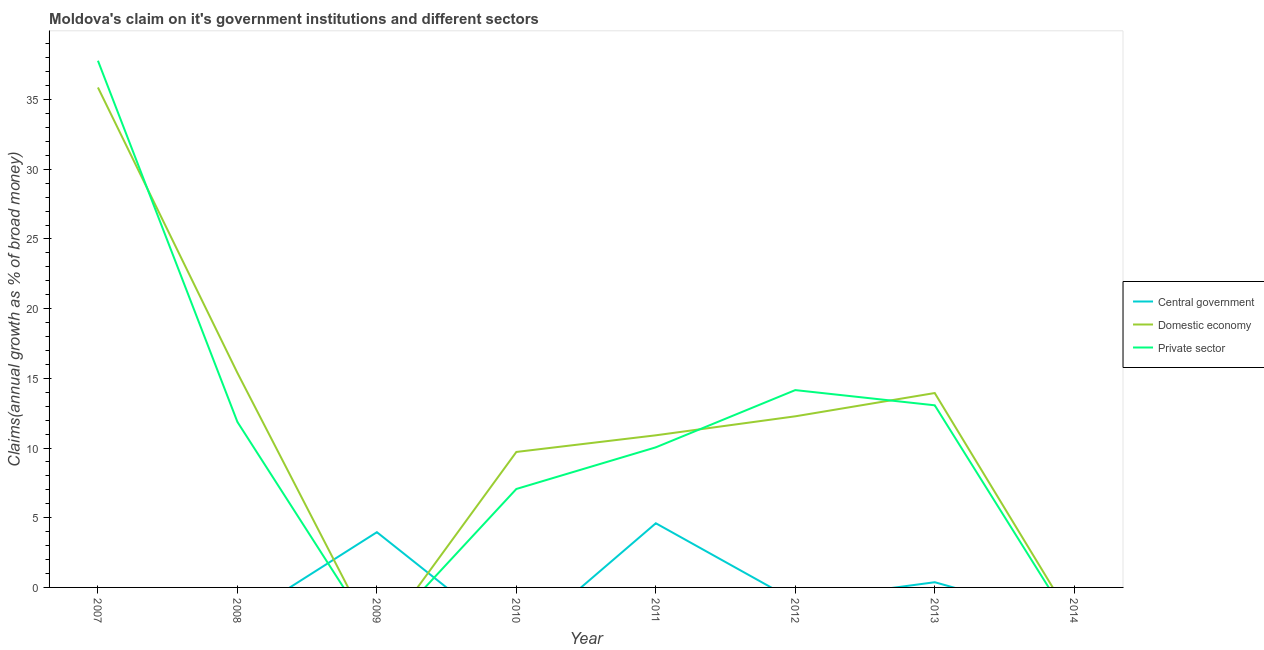What is the percentage of claim on the private sector in 2010?
Ensure brevity in your answer.  7.06. Across all years, what is the maximum percentage of claim on the domestic economy?
Offer a very short reply. 35.87. Across all years, what is the minimum percentage of claim on the central government?
Make the answer very short. 0. What is the total percentage of claim on the private sector in the graph?
Ensure brevity in your answer.  94. What is the difference between the percentage of claim on the central government in 2009 and that in 2011?
Your answer should be compact. -0.64. What is the average percentage of claim on the central government per year?
Your response must be concise. 1.12. In the year 2013, what is the difference between the percentage of claim on the private sector and percentage of claim on the domestic economy?
Give a very brief answer. -0.88. In how many years, is the percentage of claim on the central government greater than 22 %?
Offer a very short reply. 0. What is the ratio of the percentage of claim on the private sector in 2008 to that in 2013?
Your answer should be very brief. 0.91. What is the difference between the highest and the second highest percentage of claim on the private sector?
Provide a short and direct response. 23.63. What is the difference between the highest and the lowest percentage of claim on the domestic economy?
Keep it short and to the point. 35.87. Is the sum of the percentage of claim on the central government in 2009 and 2011 greater than the maximum percentage of claim on the private sector across all years?
Your answer should be very brief. No. Is it the case that in every year, the sum of the percentage of claim on the central government and percentage of claim on the domestic economy is greater than the percentage of claim on the private sector?
Make the answer very short. No. Does the percentage of claim on the private sector monotonically increase over the years?
Your answer should be compact. No. Is the percentage of claim on the central government strictly greater than the percentage of claim on the domestic economy over the years?
Your answer should be compact. No. How many years are there in the graph?
Provide a short and direct response. 8. Are the values on the major ticks of Y-axis written in scientific E-notation?
Offer a terse response. No. Does the graph contain grids?
Your answer should be compact. No. What is the title of the graph?
Provide a succinct answer. Moldova's claim on it's government institutions and different sectors. What is the label or title of the Y-axis?
Keep it short and to the point. Claims(annual growth as % of broad money). What is the Claims(annual growth as % of broad money) in Domestic economy in 2007?
Make the answer very short. 35.87. What is the Claims(annual growth as % of broad money) in Private sector in 2007?
Give a very brief answer. 37.79. What is the Claims(annual growth as % of broad money) in Central government in 2008?
Provide a succinct answer. 0. What is the Claims(annual growth as % of broad money) in Domestic economy in 2008?
Provide a short and direct response. 15.39. What is the Claims(annual growth as % of broad money) in Private sector in 2008?
Ensure brevity in your answer.  11.87. What is the Claims(annual growth as % of broad money) in Central government in 2009?
Make the answer very short. 3.96. What is the Claims(annual growth as % of broad money) in Private sector in 2009?
Offer a very short reply. 0. What is the Claims(annual growth as % of broad money) of Domestic economy in 2010?
Ensure brevity in your answer.  9.72. What is the Claims(annual growth as % of broad money) in Private sector in 2010?
Offer a very short reply. 7.06. What is the Claims(annual growth as % of broad money) of Central government in 2011?
Offer a very short reply. 4.6. What is the Claims(annual growth as % of broad money) in Domestic economy in 2011?
Your response must be concise. 10.91. What is the Claims(annual growth as % of broad money) of Private sector in 2011?
Make the answer very short. 10.05. What is the Claims(annual growth as % of broad money) of Central government in 2012?
Offer a very short reply. 0. What is the Claims(annual growth as % of broad money) in Domestic economy in 2012?
Ensure brevity in your answer.  12.28. What is the Claims(annual growth as % of broad money) of Private sector in 2012?
Keep it short and to the point. 14.16. What is the Claims(annual growth as % of broad money) in Central government in 2013?
Your answer should be compact. 0.37. What is the Claims(annual growth as % of broad money) of Domestic economy in 2013?
Give a very brief answer. 13.95. What is the Claims(annual growth as % of broad money) of Private sector in 2013?
Provide a short and direct response. 13.07. Across all years, what is the maximum Claims(annual growth as % of broad money) in Central government?
Provide a short and direct response. 4.6. Across all years, what is the maximum Claims(annual growth as % of broad money) in Domestic economy?
Your answer should be compact. 35.87. Across all years, what is the maximum Claims(annual growth as % of broad money) of Private sector?
Offer a terse response. 37.79. Across all years, what is the minimum Claims(annual growth as % of broad money) in Private sector?
Offer a terse response. 0. What is the total Claims(annual growth as % of broad money) in Central government in the graph?
Ensure brevity in your answer.  8.94. What is the total Claims(annual growth as % of broad money) in Domestic economy in the graph?
Provide a short and direct response. 98.12. What is the total Claims(annual growth as % of broad money) in Private sector in the graph?
Provide a succinct answer. 94. What is the difference between the Claims(annual growth as % of broad money) in Domestic economy in 2007 and that in 2008?
Keep it short and to the point. 20.48. What is the difference between the Claims(annual growth as % of broad money) of Private sector in 2007 and that in 2008?
Offer a very short reply. 25.92. What is the difference between the Claims(annual growth as % of broad money) of Domestic economy in 2007 and that in 2010?
Provide a short and direct response. 26.15. What is the difference between the Claims(annual growth as % of broad money) in Private sector in 2007 and that in 2010?
Offer a very short reply. 30.73. What is the difference between the Claims(annual growth as % of broad money) of Domestic economy in 2007 and that in 2011?
Your response must be concise. 24.96. What is the difference between the Claims(annual growth as % of broad money) of Private sector in 2007 and that in 2011?
Make the answer very short. 27.74. What is the difference between the Claims(annual growth as % of broad money) in Domestic economy in 2007 and that in 2012?
Ensure brevity in your answer.  23.59. What is the difference between the Claims(annual growth as % of broad money) of Private sector in 2007 and that in 2012?
Give a very brief answer. 23.63. What is the difference between the Claims(annual growth as % of broad money) in Domestic economy in 2007 and that in 2013?
Provide a succinct answer. 21.92. What is the difference between the Claims(annual growth as % of broad money) of Private sector in 2007 and that in 2013?
Your answer should be very brief. 24.72. What is the difference between the Claims(annual growth as % of broad money) in Domestic economy in 2008 and that in 2010?
Provide a succinct answer. 5.67. What is the difference between the Claims(annual growth as % of broad money) in Private sector in 2008 and that in 2010?
Give a very brief answer. 4.81. What is the difference between the Claims(annual growth as % of broad money) in Domestic economy in 2008 and that in 2011?
Your answer should be compact. 4.48. What is the difference between the Claims(annual growth as % of broad money) in Private sector in 2008 and that in 2011?
Your answer should be compact. 1.82. What is the difference between the Claims(annual growth as % of broad money) in Domestic economy in 2008 and that in 2012?
Your answer should be very brief. 3.11. What is the difference between the Claims(annual growth as % of broad money) of Private sector in 2008 and that in 2012?
Make the answer very short. -2.28. What is the difference between the Claims(annual growth as % of broad money) in Domestic economy in 2008 and that in 2013?
Give a very brief answer. 1.44. What is the difference between the Claims(annual growth as % of broad money) of Private sector in 2008 and that in 2013?
Offer a very short reply. -1.19. What is the difference between the Claims(annual growth as % of broad money) of Central government in 2009 and that in 2011?
Your response must be concise. -0.64. What is the difference between the Claims(annual growth as % of broad money) of Central government in 2009 and that in 2013?
Your response must be concise. 3.59. What is the difference between the Claims(annual growth as % of broad money) in Domestic economy in 2010 and that in 2011?
Your response must be concise. -1.19. What is the difference between the Claims(annual growth as % of broad money) in Private sector in 2010 and that in 2011?
Your answer should be compact. -2.99. What is the difference between the Claims(annual growth as % of broad money) in Domestic economy in 2010 and that in 2012?
Offer a very short reply. -2.56. What is the difference between the Claims(annual growth as % of broad money) in Private sector in 2010 and that in 2012?
Provide a short and direct response. -7.09. What is the difference between the Claims(annual growth as % of broad money) in Domestic economy in 2010 and that in 2013?
Provide a short and direct response. -4.23. What is the difference between the Claims(annual growth as % of broad money) in Private sector in 2010 and that in 2013?
Keep it short and to the point. -6. What is the difference between the Claims(annual growth as % of broad money) of Domestic economy in 2011 and that in 2012?
Give a very brief answer. -1.36. What is the difference between the Claims(annual growth as % of broad money) of Private sector in 2011 and that in 2012?
Your answer should be compact. -4.11. What is the difference between the Claims(annual growth as % of broad money) in Central government in 2011 and that in 2013?
Provide a succinct answer. 4.23. What is the difference between the Claims(annual growth as % of broad money) in Domestic economy in 2011 and that in 2013?
Make the answer very short. -3.03. What is the difference between the Claims(annual growth as % of broad money) of Private sector in 2011 and that in 2013?
Ensure brevity in your answer.  -3.02. What is the difference between the Claims(annual growth as % of broad money) in Domestic economy in 2012 and that in 2013?
Give a very brief answer. -1.67. What is the difference between the Claims(annual growth as % of broad money) of Private sector in 2012 and that in 2013?
Give a very brief answer. 1.09. What is the difference between the Claims(annual growth as % of broad money) in Domestic economy in 2007 and the Claims(annual growth as % of broad money) in Private sector in 2008?
Offer a very short reply. 24. What is the difference between the Claims(annual growth as % of broad money) in Domestic economy in 2007 and the Claims(annual growth as % of broad money) in Private sector in 2010?
Offer a very short reply. 28.81. What is the difference between the Claims(annual growth as % of broad money) of Domestic economy in 2007 and the Claims(annual growth as % of broad money) of Private sector in 2011?
Ensure brevity in your answer.  25.82. What is the difference between the Claims(annual growth as % of broad money) in Domestic economy in 2007 and the Claims(annual growth as % of broad money) in Private sector in 2012?
Offer a terse response. 21.71. What is the difference between the Claims(annual growth as % of broad money) of Domestic economy in 2007 and the Claims(annual growth as % of broad money) of Private sector in 2013?
Ensure brevity in your answer.  22.8. What is the difference between the Claims(annual growth as % of broad money) of Domestic economy in 2008 and the Claims(annual growth as % of broad money) of Private sector in 2010?
Provide a short and direct response. 8.33. What is the difference between the Claims(annual growth as % of broad money) in Domestic economy in 2008 and the Claims(annual growth as % of broad money) in Private sector in 2011?
Give a very brief answer. 5.34. What is the difference between the Claims(annual growth as % of broad money) of Domestic economy in 2008 and the Claims(annual growth as % of broad money) of Private sector in 2012?
Keep it short and to the point. 1.23. What is the difference between the Claims(annual growth as % of broad money) in Domestic economy in 2008 and the Claims(annual growth as % of broad money) in Private sector in 2013?
Offer a very short reply. 2.32. What is the difference between the Claims(annual growth as % of broad money) of Central government in 2009 and the Claims(annual growth as % of broad money) of Domestic economy in 2010?
Provide a short and direct response. -5.76. What is the difference between the Claims(annual growth as % of broad money) in Central government in 2009 and the Claims(annual growth as % of broad money) in Private sector in 2010?
Your answer should be compact. -3.1. What is the difference between the Claims(annual growth as % of broad money) of Central government in 2009 and the Claims(annual growth as % of broad money) of Domestic economy in 2011?
Provide a succinct answer. -6.95. What is the difference between the Claims(annual growth as % of broad money) of Central government in 2009 and the Claims(annual growth as % of broad money) of Private sector in 2011?
Provide a short and direct response. -6.09. What is the difference between the Claims(annual growth as % of broad money) in Central government in 2009 and the Claims(annual growth as % of broad money) in Domestic economy in 2012?
Provide a succinct answer. -8.31. What is the difference between the Claims(annual growth as % of broad money) of Central government in 2009 and the Claims(annual growth as % of broad money) of Private sector in 2012?
Offer a very short reply. -10.19. What is the difference between the Claims(annual growth as % of broad money) of Central government in 2009 and the Claims(annual growth as % of broad money) of Domestic economy in 2013?
Keep it short and to the point. -9.98. What is the difference between the Claims(annual growth as % of broad money) of Central government in 2009 and the Claims(annual growth as % of broad money) of Private sector in 2013?
Offer a very short reply. -9.1. What is the difference between the Claims(annual growth as % of broad money) in Domestic economy in 2010 and the Claims(annual growth as % of broad money) in Private sector in 2011?
Make the answer very short. -0.33. What is the difference between the Claims(annual growth as % of broad money) of Domestic economy in 2010 and the Claims(annual growth as % of broad money) of Private sector in 2012?
Keep it short and to the point. -4.44. What is the difference between the Claims(annual growth as % of broad money) of Domestic economy in 2010 and the Claims(annual growth as % of broad money) of Private sector in 2013?
Keep it short and to the point. -3.35. What is the difference between the Claims(annual growth as % of broad money) of Central government in 2011 and the Claims(annual growth as % of broad money) of Domestic economy in 2012?
Your answer should be compact. -7.67. What is the difference between the Claims(annual growth as % of broad money) in Central government in 2011 and the Claims(annual growth as % of broad money) in Private sector in 2012?
Provide a succinct answer. -9.55. What is the difference between the Claims(annual growth as % of broad money) of Domestic economy in 2011 and the Claims(annual growth as % of broad money) of Private sector in 2012?
Your answer should be compact. -3.24. What is the difference between the Claims(annual growth as % of broad money) of Central government in 2011 and the Claims(annual growth as % of broad money) of Domestic economy in 2013?
Ensure brevity in your answer.  -9.34. What is the difference between the Claims(annual growth as % of broad money) in Central government in 2011 and the Claims(annual growth as % of broad money) in Private sector in 2013?
Your answer should be very brief. -8.46. What is the difference between the Claims(annual growth as % of broad money) of Domestic economy in 2011 and the Claims(annual growth as % of broad money) of Private sector in 2013?
Your response must be concise. -2.15. What is the difference between the Claims(annual growth as % of broad money) in Domestic economy in 2012 and the Claims(annual growth as % of broad money) in Private sector in 2013?
Offer a very short reply. -0.79. What is the average Claims(annual growth as % of broad money) of Central government per year?
Offer a very short reply. 1.12. What is the average Claims(annual growth as % of broad money) in Domestic economy per year?
Keep it short and to the point. 12.27. What is the average Claims(annual growth as % of broad money) of Private sector per year?
Ensure brevity in your answer.  11.75. In the year 2007, what is the difference between the Claims(annual growth as % of broad money) in Domestic economy and Claims(annual growth as % of broad money) in Private sector?
Offer a terse response. -1.92. In the year 2008, what is the difference between the Claims(annual growth as % of broad money) in Domestic economy and Claims(annual growth as % of broad money) in Private sector?
Offer a terse response. 3.52. In the year 2010, what is the difference between the Claims(annual growth as % of broad money) in Domestic economy and Claims(annual growth as % of broad money) in Private sector?
Ensure brevity in your answer.  2.66. In the year 2011, what is the difference between the Claims(annual growth as % of broad money) in Central government and Claims(annual growth as % of broad money) in Domestic economy?
Make the answer very short. -6.31. In the year 2011, what is the difference between the Claims(annual growth as % of broad money) in Central government and Claims(annual growth as % of broad money) in Private sector?
Offer a very short reply. -5.45. In the year 2011, what is the difference between the Claims(annual growth as % of broad money) of Domestic economy and Claims(annual growth as % of broad money) of Private sector?
Offer a very short reply. 0.86. In the year 2012, what is the difference between the Claims(annual growth as % of broad money) in Domestic economy and Claims(annual growth as % of broad money) in Private sector?
Your answer should be very brief. -1.88. In the year 2013, what is the difference between the Claims(annual growth as % of broad money) in Central government and Claims(annual growth as % of broad money) in Domestic economy?
Offer a terse response. -13.57. In the year 2013, what is the difference between the Claims(annual growth as % of broad money) of Central government and Claims(annual growth as % of broad money) of Private sector?
Your response must be concise. -12.69. In the year 2013, what is the difference between the Claims(annual growth as % of broad money) of Domestic economy and Claims(annual growth as % of broad money) of Private sector?
Keep it short and to the point. 0.88. What is the ratio of the Claims(annual growth as % of broad money) in Domestic economy in 2007 to that in 2008?
Offer a terse response. 2.33. What is the ratio of the Claims(annual growth as % of broad money) in Private sector in 2007 to that in 2008?
Provide a succinct answer. 3.18. What is the ratio of the Claims(annual growth as % of broad money) of Domestic economy in 2007 to that in 2010?
Make the answer very short. 3.69. What is the ratio of the Claims(annual growth as % of broad money) in Private sector in 2007 to that in 2010?
Your answer should be compact. 5.35. What is the ratio of the Claims(annual growth as % of broad money) of Domestic economy in 2007 to that in 2011?
Your answer should be very brief. 3.29. What is the ratio of the Claims(annual growth as % of broad money) of Private sector in 2007 to that in 2011?
Make the answer very short. 3.76. What is the ratio of the Claims(annual growth as % of broad money) of Domestic economy in 2007 to that in 2012?
Make the answer very short. 2.92. What is the ratio of the Claims(annual growth as % of broad money) in Private sector in 2007 to that in 2012?
Offer a terse response. 2.67. What is the ratio of the Claims(annual growth as % of broad money) in Domestic economy in 2007 to that in 2013?
Make the answer very short. 2.57. What is the ratio of the Claims(annual growth as % of broad money) of Private sector in 2007 to that in 2013?
Make the answer very short. 2.89. What is the ratio of the Claims(annual growth as % of broad money) in Domestic economy in 2008 to that in 2010?
Provide a short and direct response. 1.58. What is the ratio of the Claims(annual growth as % of broad money) in Private sector in 2008 to that in 2010?
Your answer should be compact. 1.68. What is the ratio of the Claims(annual growth as % of broad money) of Domestic economy in 2008 to that in 2011?
Give a very brief answer. 1.41. What is the ratio of the Claims(annual growth as % of broad money) in Private sector in 2008 to that in 2011?
Provide a short and direct response. 1.18. What is the ratio of the Claims(annual growth as % of broad money) in Domestic economy in 2008 to that in 2012?
Provide a short and direct response. 1.25. What is the ratio of the Claims(annual growth as % of broad money) in Private sector in 2008 to that in 2012?
Your response must be concise. 0.84. What is the ratio of the Claims(annual growth as % of broad money) in Domestic economy in 2008 to that in 2013?
Offer a terse response. 1.1. What is the ratio of the Claims(annual growth as % of broad money) of Private sector in 2008 to that in 2013?
Ensure brevity in your answer.  0.91. What is the ratio of the Claims(annual growth as % of broad money) of Central government in 2009 to that in 2011?
Ensure brevity in your answer.  0.86. What is the ratio of the Claims(annual growth as % of broad money) in Central government in 2009 to that in 2013?
Offer a terse response. 10.61. What is the ratio of the Claims(annual growth as % of broad money) of Domestic economy in 2010 to that in 2011?
Give a very brief answer. 0.89. What is the ratio of the Claims(annual growth as % of broad money) of Private sector in 2010 to that in 2011?
Offer a very short reply. 0.7. What is the ratio of the Claims(annual growth as % of broad money) of Domestic economy in 2010 to that in 2012?
Keep it short and to the point. 0.79. What is the ratio of the Claims(annual growth as % of broad money) in Private sector in 2010 to that in 2012?
Provide a short and direct response. 0.5. What is the ratio of the Claims(annual growth as % of broad money) of Domestic economy in 2010 to that in 2013?
Your answer should be compact. 0.7. What is the ratio of the Claims(annual growth as % of broad money) of Private sector in 2010 to that in 2013?
Offer a very short reply. 0.54. What is the ratio of the Claims(annual growth as % of broad money) of Domestic economy in 2011 to that in 2012?
Keep it short and to the point. 0.89. What is the ratio of the Claims(annual growth as % of broad money) in Private sector in 2011 to that in 2012?
Offer a very short reply. 0.71. What is the ratio of the Claims(annual growth as % of broad money) of Central government in 2011 to that in 2013?
Your answer should be very brief. 12.33. What is the ratio of the Claims(annual growth as % of broad money) in Domestic economy in 2011 to that in 2013?
Ensure brevity in your answer.  0.78. What is the ratio of the Claims(annual growth as % of broad money) in Private sector in 2011 to that in 2013?
Make the answer very short. 0.77. What is the ratio of the Claims(annual growth as % of broad money) in Domestic economy in 2012 to that in 2013?
Give a very brief answer. 0.88. What is the ratio of the Claims(annual growth as % of broad money) in Private sector in 2012 to that in 2013?
Ensure brevity in your answer.  1.08. What is the difference between the highest and the second highest Claims(annual growth as % of broad money) of Central government?
Offer a terse response. 0.64. What is the difference between the highest and the second highest Claims(annual growth as % of broad money) of Domestic economy?
Keep it short and to the point. 20.48. What is the difference between the highest and the second highest Claims(annual growth as % of broad money) in Private sector?
Provide a short and direct response. 23.63. What is the difference between the highest and the lowest Claims(annual growth as % of broad money) in Central government?
Ensure brevity in your answer.  4.6. What is the difference between the highest and the lowest Claims(annual growth as % of broad money) in Domestic economy?
Make the answer very short. 35.87. What is the difference between the highest and the lowest Claims(annual growth as % of broad money) of Private sector?
Your response must be concise. 37.79. 